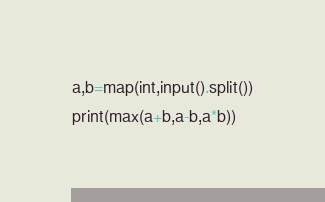Convert code to text. <code><loc_0><loc_0><loc_500><loc_500><_Python_>a,b=map(int,input().split())
print(max(a+b,a-b,a*b))</code> 